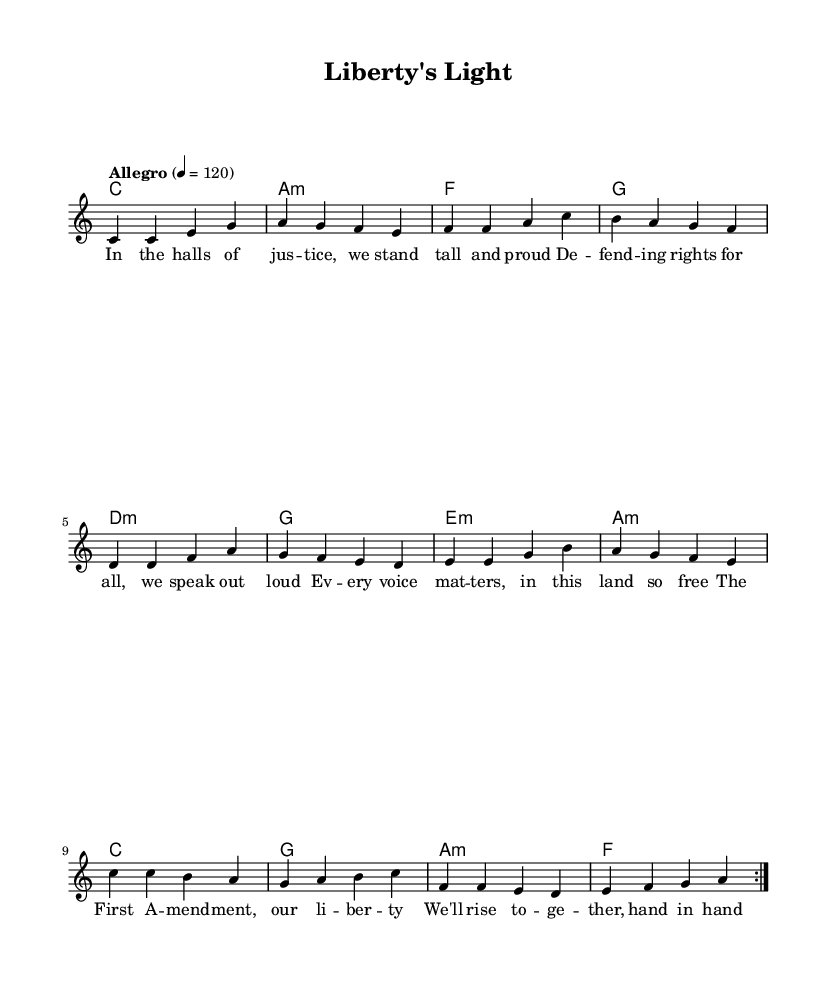What is the key signature of this music? The key signature shown at the beginning of the score indicates C major, which has no sharps or flats.
Answer: C major What is the time signature of this piece? The time signature is specified in the first part of the musical notation as 4/4, which means there are four beats per measure.
Answer: 4/4 What is the tempo marking given in the score? The tempo marking at the beginning indicates "Allegro" with a metronome setting of 120 beats per minute, indicating a brisk pace.
Answer: Allegro How many measures are repeated in the melody? The melody shows a repeat sign, indicating that the section of music is to be played twice, which encompasses the number of measures stated.
Answer: 8 measures What phrase from the lyrics emphasizes unity in social justice? The pre-chorus section indicates a commitment to working together in the fight for equality, specifically mentioning "hand in hand."
Answer: hand in hand What is the harmonic progression for the chorus? The chords used in the chorus section are C major, G major, A minor, and F major, which create a strong and uplifting harmonic context suitable for pop music.
Answer: C, G, A minor, F 